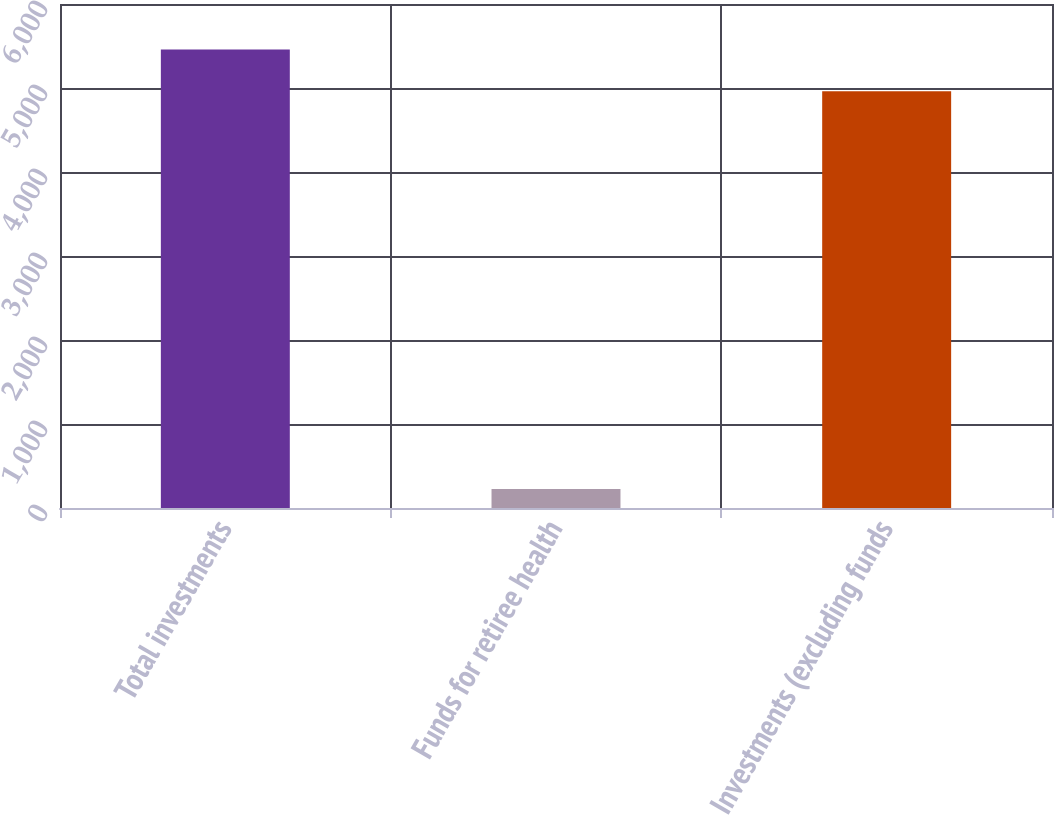<chart> <loc_0><loc_0><loc_500><loc_500><bar_chart><fcel>Total investments<fcel>Funds for retiree health<fcel>Investments (excluding funds<nl><fcel>5457.1<fcel>226<fcel>4961<nl></chart> 